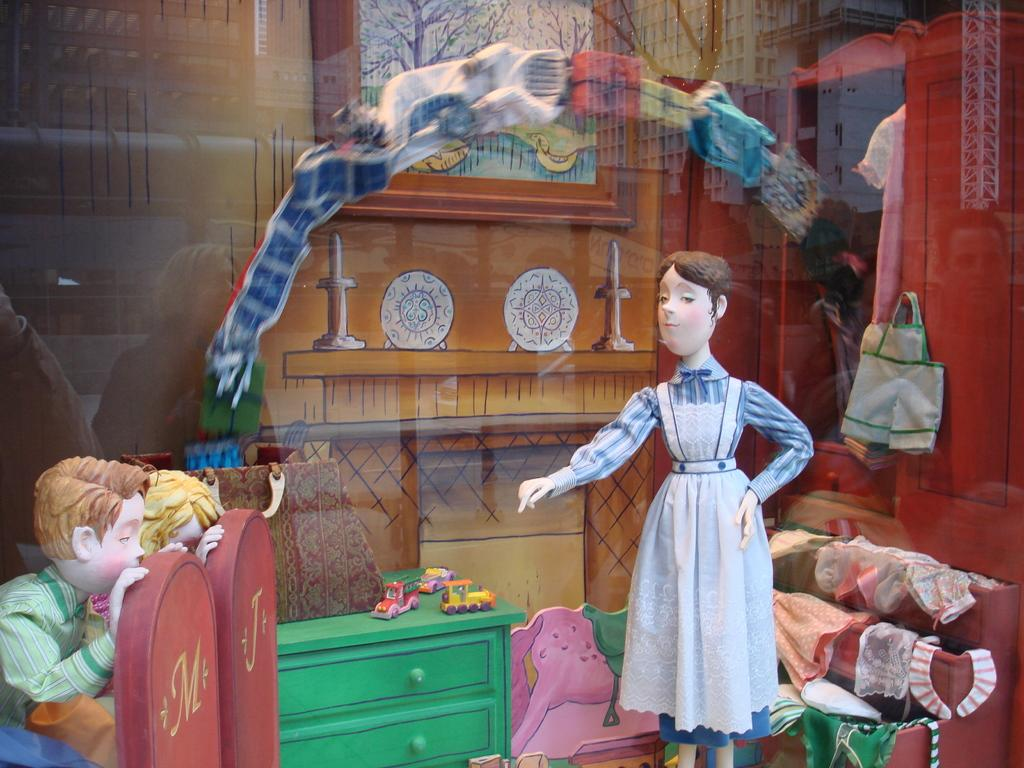What objects can be seen in the image? There are toys in the image. Can you describe any other elements in the image? There are reflections of persons on the glass in the image. What type of pancake is being served on the roof in the image? There is no pancake or roof present in the image; it only features toys and reflections of persons on the glass. 